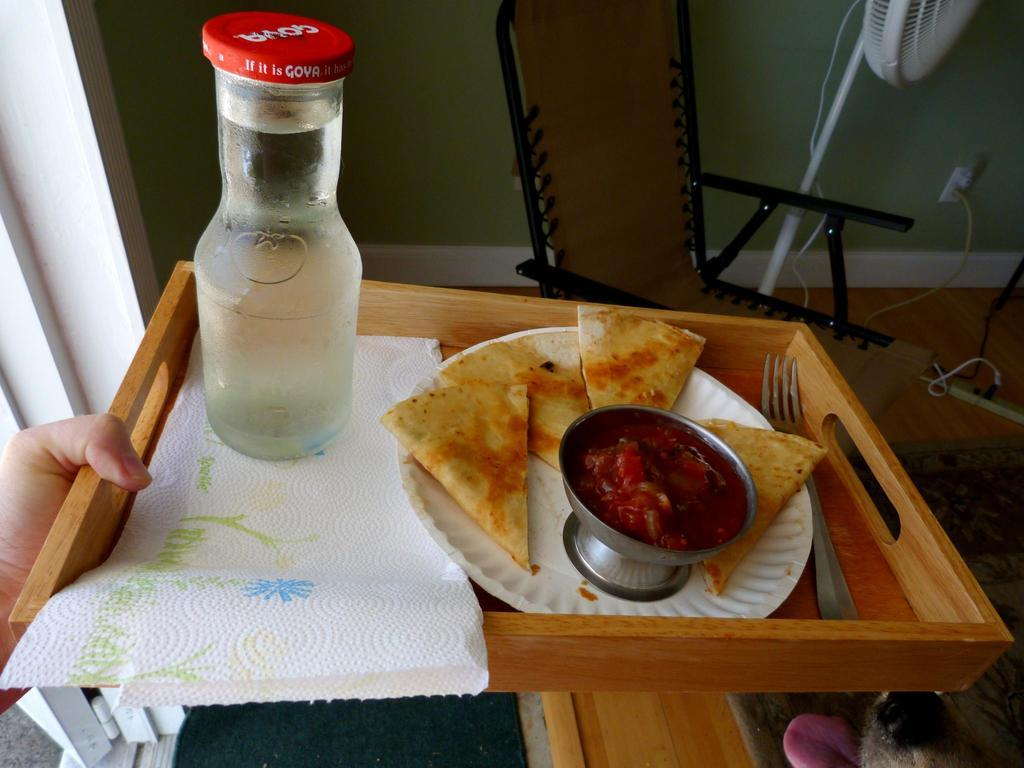<image>
Present a compact description of the photo's key features. the word Goya is on the red cap 